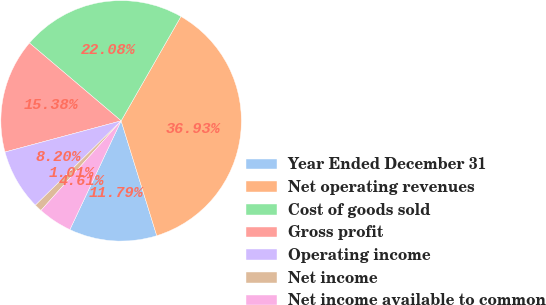<chart> <loc_0><loc_0><loc_500><loc_500><pie_chart><fcel>Year Ended December 31<fcel>Net operating revenues<fcel>Cost of goods sold<fcel>Gross profit<fcel>Operating income<fcel>Net income<fcel>Net income available to common<nl><fcel>11.79%<fcel>36.93%<fcel>22.08%<fcel>15.38%<fcel>8.2%<fcel>1.01%<fcel>4.61%<nl></chart> 